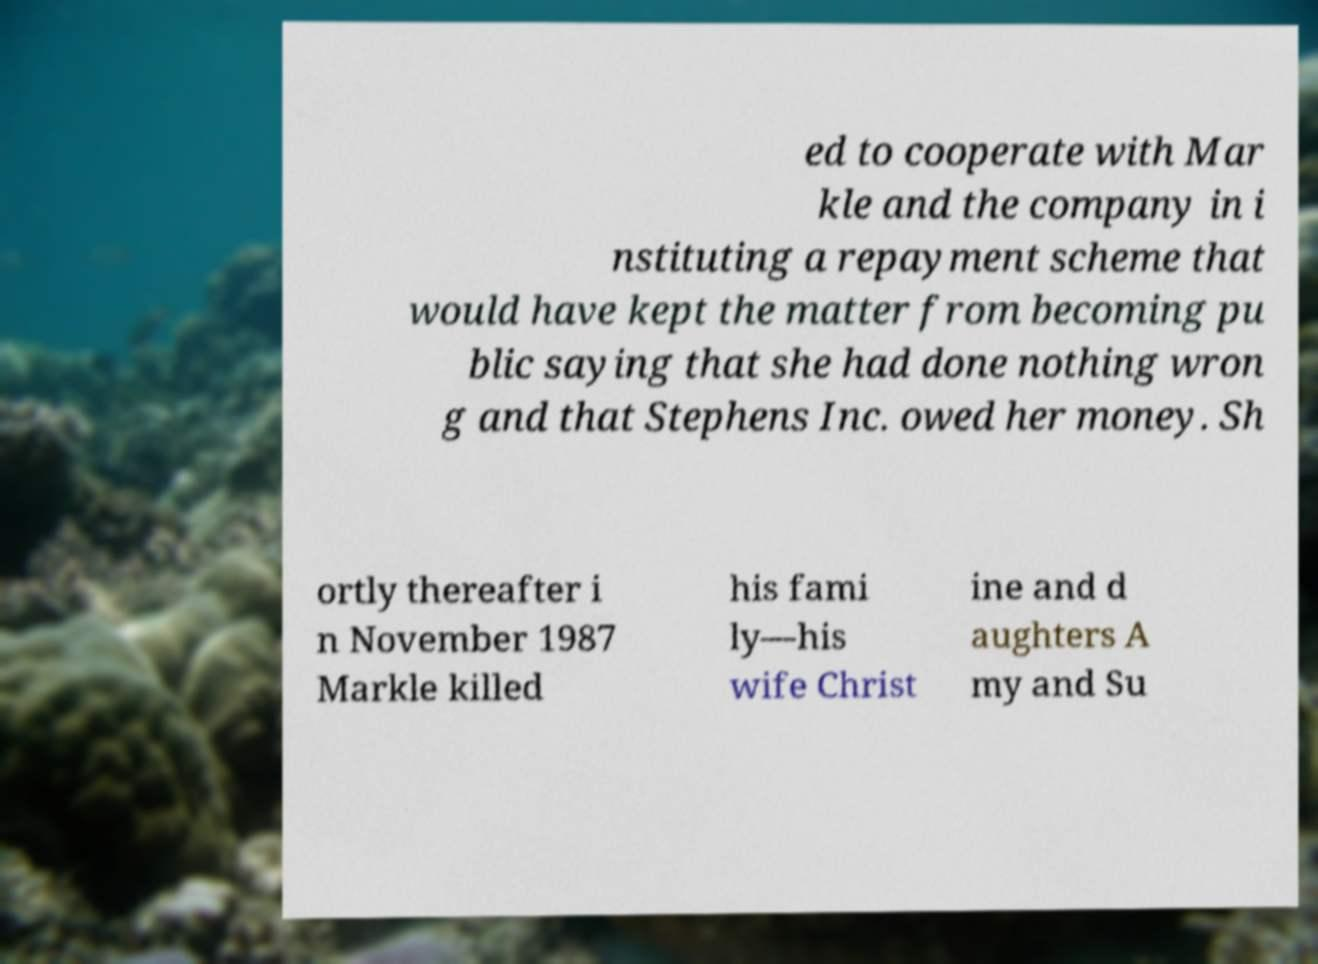Please identify and transcribe the text found in this image. ed to cooperate with Mar kle and the company in i nstituting a repayment scheme that would have kept the matter from becoming pu blic saying that she had done nothing wron g and that Stephens Inc. owed her money. Sh ortly thereafter i n November 1987 Markle killed his fami ly—his wife Christ ine and d aughters A my and Su 